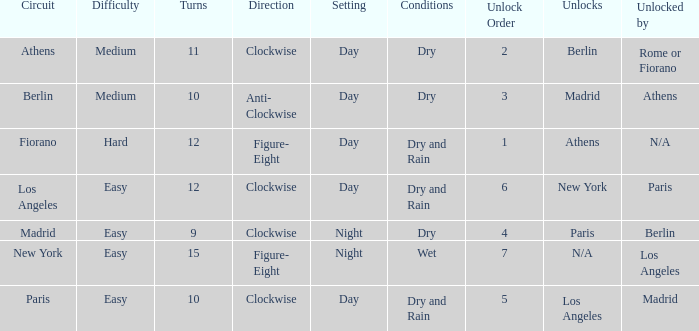How many instances is the unlocked n/a? 1.0. 